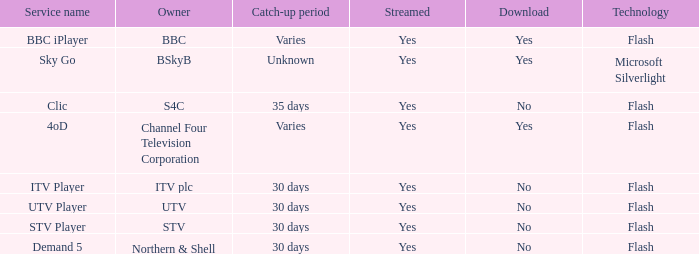Help me parse the entirety of this table. {'header': ['Service name', 'Owner', 'Catch-up period', 'Streamed', 'Download', 'Technology'], 'rows': [['BBC iPlayer', 'BBC', 'Varies', 'Yes', 'Yes', 'Flash'], ['Sky Go', 'BSkyB', 'Unknown', 'Yes', 'Yes', 'Microsoft Silverlight'], ['Clic', 'S4C', '35 days', 'Yes', 'No', 'Flash'], ['4oD', 'Channel Four Television Corporation', 'Varies', 'Yes', 'Yes', 'Flash'], ['ITV Player', 'ITV plc', '30 days', 'Yes', 'No', 'Flash'], ['UTV Player', 'UTV', '30 days', 'Yes', 'No', 'Flash'], ['STV Player', 'STV', '30 days', 'Yes', 'No', 'Flash'], ['Demand 5', 'Northern & Shell', '30 days', 'Yes', 'No', 'Flash']]} What is the download of the varies catch-up period? Yes, Yes. 